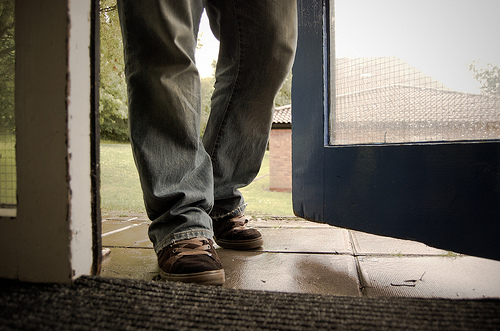<image>
Is the shoe above the rug? No. The shoe is not positioned above the rug. The vertical arrangement shows a different relationship. 